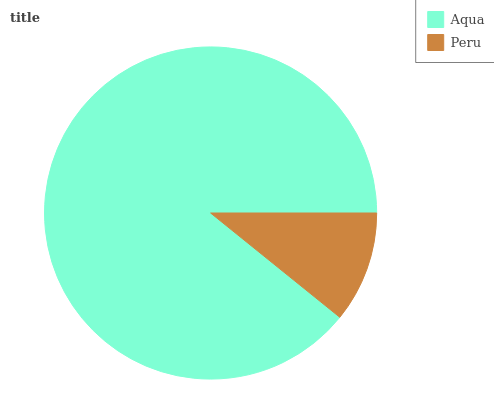Is Peru the minimum?
Answer yes or no. Yes. Is Aqua the maximum?
Answer yes or no. Yes. Is Peru the maximum?
Answer yes or no. No. Is Aqua greater than Peru?
Answer yes or no. Yes. Is Peru less than Aqua?
Answer yes or no. Yes. Is Peru greater than Aqua?
Answer yes or no. No. Is Aqua less than Peru?
Answer yes or no. No. Is Aqua the high median?
Answer yes or no. Yes. Is Peru the low median?
Answer yes or no. Yes. Is Peru the high median?
Answer yes or no. No. Is Aqua the low median?
Answer yes or no. No. 